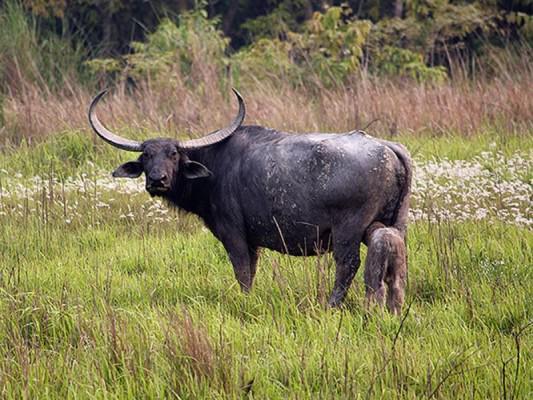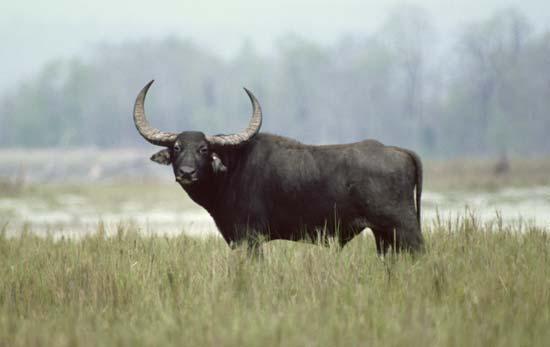The first image is the image on the left, the second image is the image on the right. Considering the images on both sides, is "A calf has its head and neck bent under a standing adult horned animal to nurse." valid? Answer yes or no. Yes. 